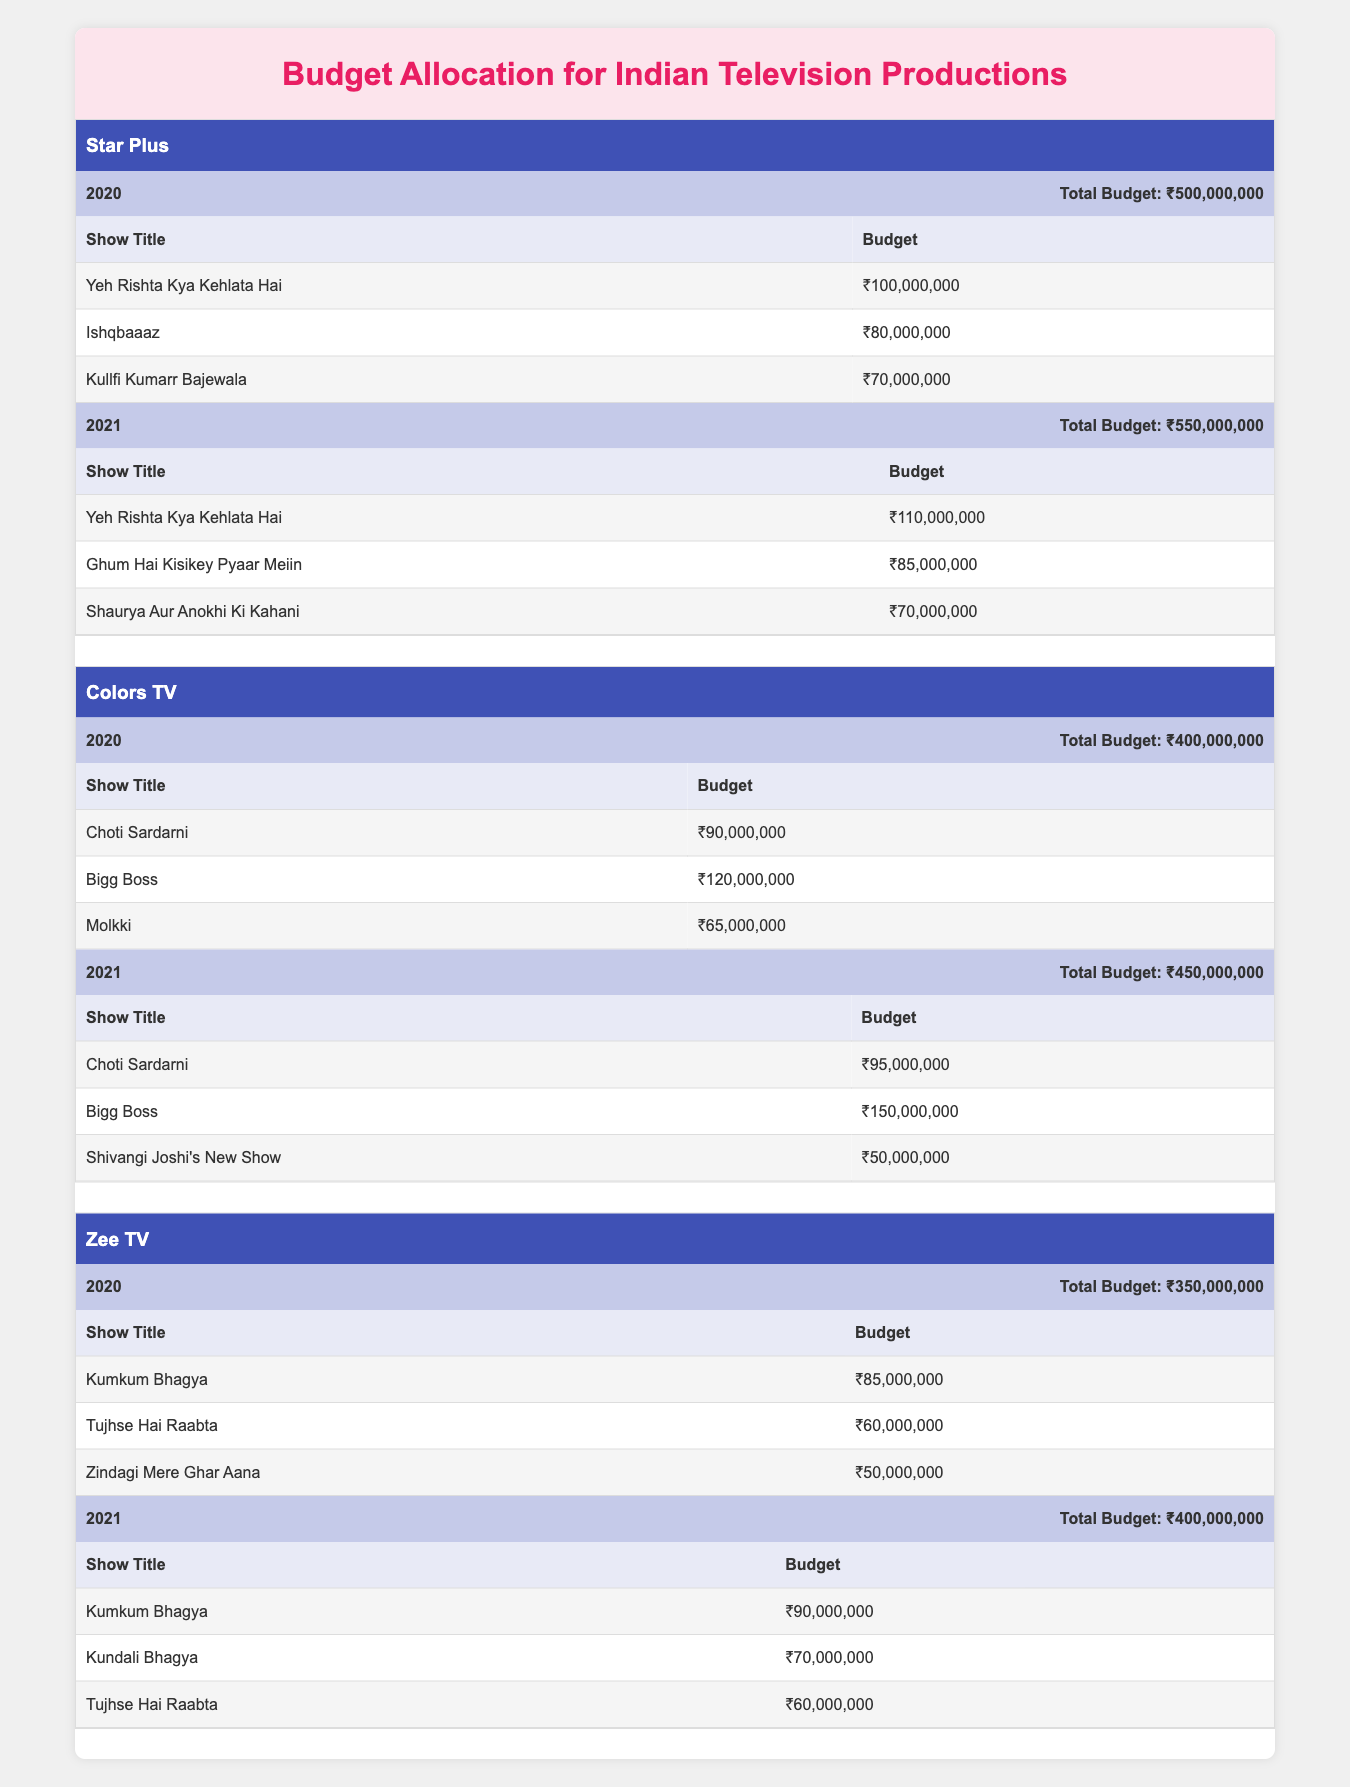What is the total budget allocated by Star Plus in 2021? In 2021, Star Plus allocated a total budget of ₹550,000,000 as mentioned in the year allocation section for that year.
Answer: ₹550,000,000 Which show received the highest budget on Colors TV in 2020? The show "Bigg Boss" received the highest budget on Colors TV in 2020, which is ₹120,000,000, as indicated in the budget for shows in that year.
Answer: ₹120,000,000 What is the average budget allocated for shows on Zee TV in 2021? The total budget for Zee TV in 2021 is ₹400,000,000. There are three shows: "Kumkum Bhagya" (₹90,000,000), "Kundali Bhagya" (₹70,000,000), and "Tujhse Hai Raabta" (₹60,000,000). The average is calculated as (90 + 70 + 60) / 3 = ₹220,000,000 / 3 = ₹73,333,333.33.
Answer: ₹73,333,333.33 Did Colors TV allocate a higher budget in 2021 compared to Star Plus? Colors TV allocated ₹450,000,000 in 2021 and Star Plus allocated ₹550,000,000. Since ₹450,000,000 is less than ₹550,000,000, the statement is false.
Answer: No How much more budget did Star Plus allocate in 2021 compared to 2020? Star Plus allocated ₹550,000,000 in 2021 and ₹500,000,000 in 2020. The difference is ₹550,000,000 - ₹500,000,000 = ₹50,000,000.
Answer: ₹50,000,000 Which channel had the lowest total budget in 2020 and what was that budget? In 2020, Zee TV had the lowest total budget of ₹350,000,000. This is evidenced by the budget allocations shown for each channel for that year.
Answer: ₹350,000,000 What percentage of the total budget allocation for Colors TV in 2021 was spent on "Bigg Boss"? Colors TV’s total budget in 2021 is ₹450,000,000, and "Bigg Boss" received ₹150,000,000. The percentage is calculated as (150,000,000 / 450,000,000) * 100 = 33.33%.
Answer: 33.33% Which show had the second highest budget on Zee TV in 2020? The show "Tujhse Hai Raabta" had the second highest budget of ₹60,000,000 on Zee TV in 2020, following "Kumkum Bhagya," which had a higher budget.
Answer: ₹60,000,000 Has the budget allocation for “Yeh Rishta Kya Kehlata Hai” increased from 2020 to 2021? In 2020, “Yeh Rishta Kya Kehlata Hai” had a budget of ₹100,000,000, and in 2021 it increased to ₹110,000,000. Therefore, the show’s budget did increase.
Answer: Yes 